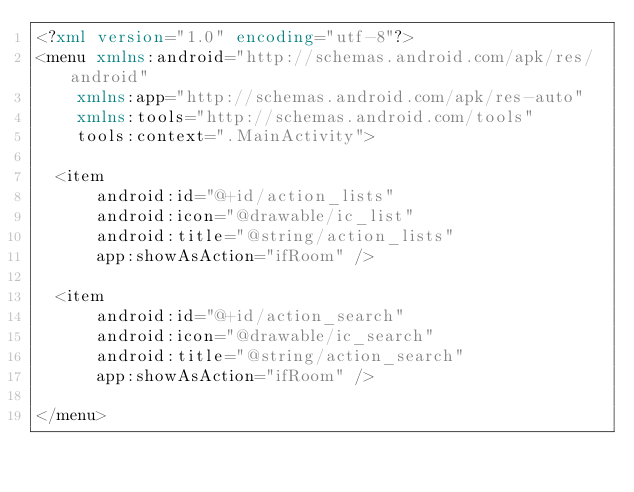<code> <loc_0><loc_0><loc_500><loc_500><_XML_><?xml version="1.0" encoding="utf-8"?>
<menu xmlns:android="http://schemas.android.com/apk/res/android"
    xmlns:app="http://schemas.android.com/apk/res-auto"
    xmlns:tools="http://schemas.android.com/tools"
    tools:context=".MainActivity">

  <item
      android:id="@+id/action_lists"
      android:icon="@drawable/ic_list"
      android:title="@string/action_lists"
      app:showAsAction="ifRoom" />

  <item
      android:id="@+id/action_search"
      android:icon="@drawable/ic_search"
      android:title="@string/action_search"
      app:showAsAction="ifRoom" />

</menu></code> 